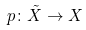Convert formula to latex. <formula><loc_0><loc_0><loc_500><loc_500>p \colon \tilde { X } \rightarrow X</formula> 